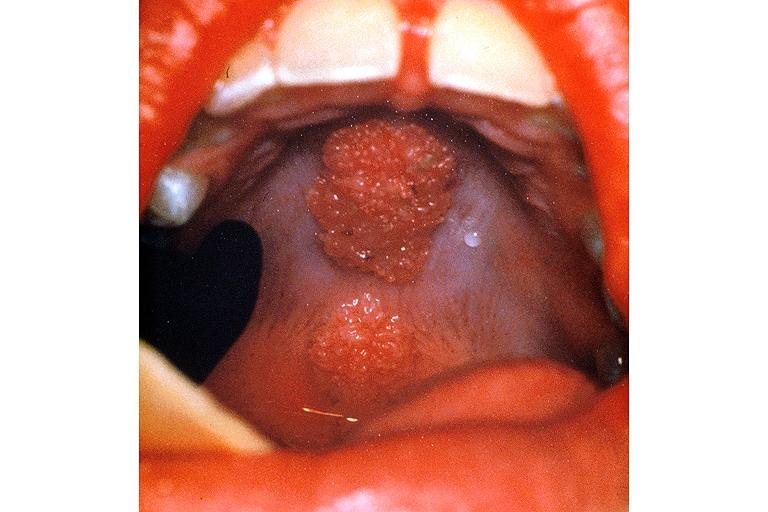does this image show condyloma accuminatum?
Answer the question using a single word or phrase. Yes 